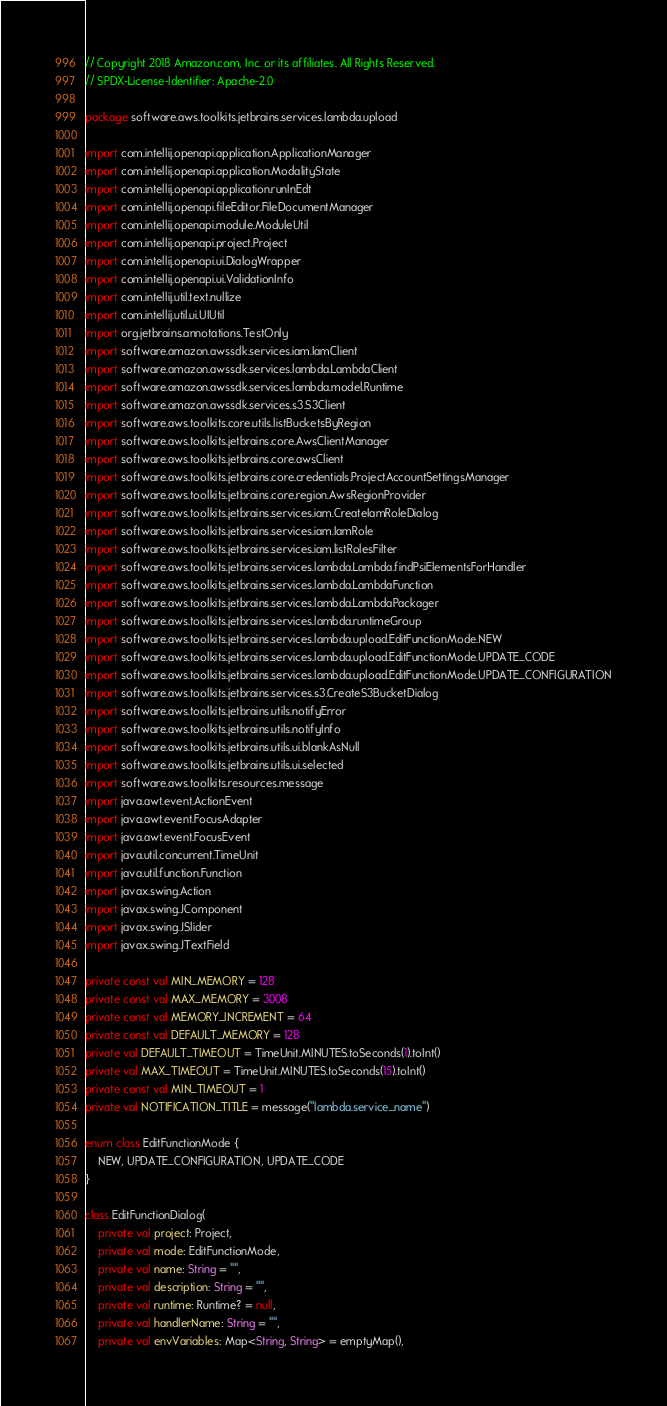Convert code to text. <code><loc_0><loc_0><loc_500><loc_500><_Kotlin_>// Copyright 2018 Amazon.com, Inc. or its affiliates. All Rights Reserved.
// SPDX-License-Identifier: Apache-2.0

package software.aws.toolkits.jetbrains.services.lambda.upload

import com.intellij.openapi.application.ApplicationManager
import com.intellij.openapi.application.ModalityState
import com.intellij.openapi.application.runInEdt
import com.intellij.openapi.fileEditor.FileDocumentManager
import com.intellij.openapi.module.ModuleUtil
import com.intellij.openapi.project.Project
import com.intellij.openapi.ui.DialogWrapper
import com.intellij.openapi.ui.ValidationInfo
import com.intellij.util.text.nullize
import com.intellij.util.ui.UIUtil
import org.jetbrains.annotations.TestOnly
import software.amazon.awssdk.services.iam.IamClient
import software.amazon.awssdk.services.lambda.LambdaClient
import software.amazon.awssdk.services.lambda.model.Runtime
import software.amazon.awssdk.services.s3.S3Client
import software.aws.toolkits.core.utils.listBucketsByRegion
import software.aws.toolkits.jetbrains.core.AwsClientManager
import software.aws.toolkits.jetbrains.core.awsClient
import software.aws.toolkits.jetbrains.core.credentials.ProjectAccountSettingsManager
import software.aws.toolkits.jetbrains.core.region.AwsRegionProvider
import software.aws.toolkits.jetbrains.services.iam.CreateIamRoleDialog
import software.aws.toolkits.jetbrains.services.iam.IamRole
import software.aws.toolkits.jetbrains.services.iam.listRolesFilter
import software.aws.toolkits.jetbrains.services.lambda.Lambda.findPsiElementsForHandler
import software.aws.toolkits.jetbrains.services.lambda.LambdaFunction
import software.aws.toolkits.jetbrains.services.lambda.LambdaPackager
import software.aws.toolkits.jetbrains.services.lambda.runtimeGroup
import software.aws.toolkits.jetbrains.services.lambda.upload.EditFunctionMode.NEW
import software.aws.toolkits.jetbrains.services.lambda.upload.EditFunctionMode.UPDATE_CODE
import software.aws.toolkits.jetbrains.services.lambda.upload.EditFunctionMode.UPDATE_CONFIGURATION
import software.aws.toolkits.jetbrains.services.s3.CreateS3BucketDialog
import software.aws.toolkits.jetbrains.utils.notifyError
import software.aws.toolkits.jetbrains.utils.notifyInfo
import software.aws.toolkits.jetbrains.utils.ui.blankAsNull
import software.aws.toolkits.jetbrains.utils.ui.selected
import software.aws.toolkits.resources.message
import java.awt.event.ActionEvent
import java.awt.event.FocusAdapter
import java.awt.event.FocusEvent
import java.util.concurrent.TimeUnit
import java.util.function.Function
import javax.swing.Action
import javax.swing.JComponent
import javax.swing.JSlider
import javax.swing.JTextField

private const val MIN_MEMORY = 128
private const val MAX_MEMORY = 3008
private const val MEMORY_INCREMENT = 64
private const val DEFAULT_MEMORY = 128
private val DEFAULT_TIMEOUT = TimeUnit.MINUTES.toSeconds(1).toInt()
private val MAX_TIMEOUT = TimeUnit.MINUTES.toSeconds(15).toInt()
private const val MIN_TIMEOUT = 1
private val NOTIFICATION_TITLE = message("lambda.service_name")

enum class EditFunctionMode {
    NEW, UPDATE_CONFIGURATION, UPDATE_CODE
}

class EditFunctionDialog(
    private val project: Project,
    private val mode: EditFunctionMode,
    private val name: String = "",
    private val description: String = "",
    private val runtime: Runtime? = null,
    private val handlerName: String = "",
    private val envVariables: Map<String, String> = emptyMap(),</code> 